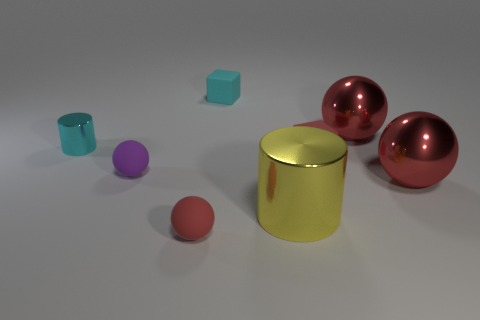How are the shadows in the scene oriented? The shadows in the scene are oriented towards the lower right-hand side, indicating a light source coming from the upper left-hand side of the composition. What does the direction of the shadows tell us about the light source? The direction of the shadows suggests that the light source is positioned above and to the left of the objects, casting their shadows diagonally away from it. This implies a single, focused light source illuminating the scene. 